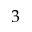Convert formula to latex. <formula><loc_0><loc_0><loc_500><loc_500>3</formula> 